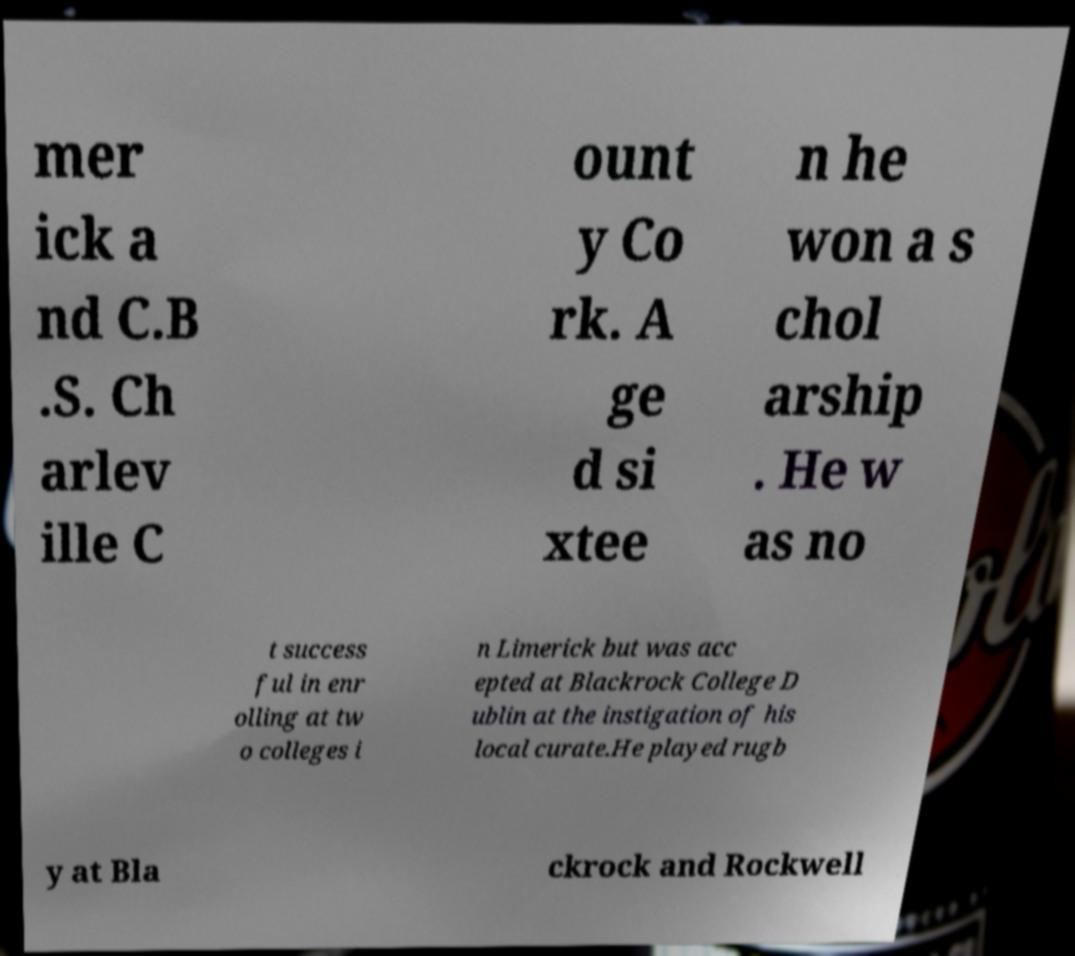Can you read and provide the text displayed in the image?This photo seems to have some interesting text. Can you extract and type it out for me? mer ick a nd C.B .S. Ch arlev ille C ount y Co rk. A ge d si xtee n he won a s chol arship . He w as no t success ful in enr olling at tw o colleges i n Limerick but was acc epted at Blackrock College D ublin at the instigation of his local curate.He played rugb y at Bla ckrock and Rockwell 